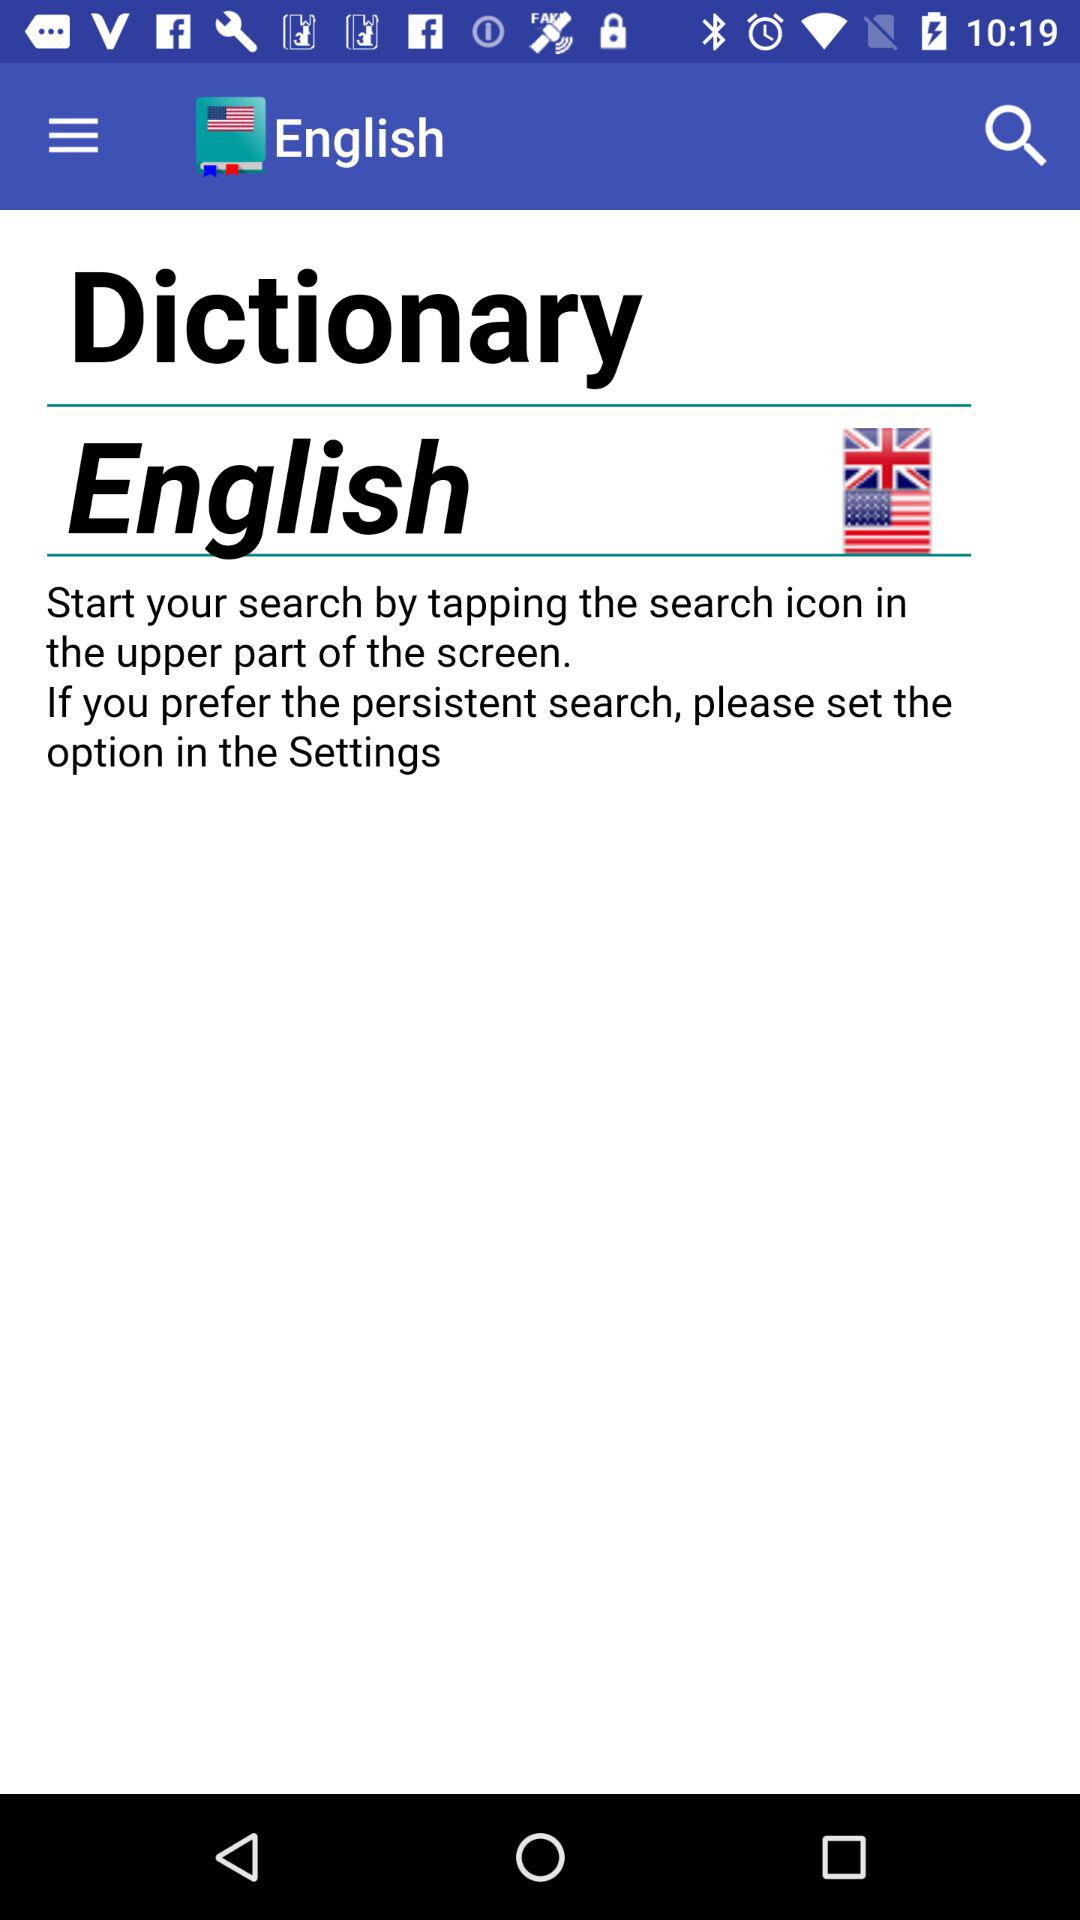What is the app name? The app name is "Dictionary English". 